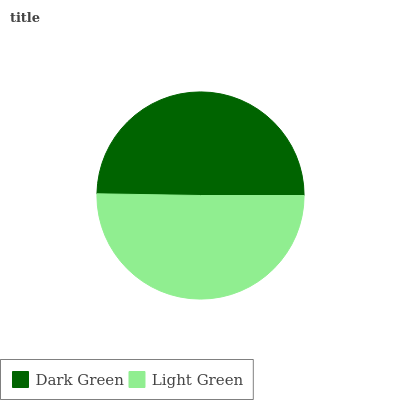Is Dark Green the minimum?
Answer yes or no. Yes. Is Light Green the maximum?
Answer yes or no. Yes. Is Light Green the minimum?
Answer yes or no. No. Is Light Green greater than Dark Green?
Answer yes or no. Yes. Is Dark Green less than Light Green?
Answer yes or no. Yes. Is Dark Green greater than Light Green?
Answer yes or no. No. Is Light Green less than Dark Green?
Answer yes or no. No. Is Light Green the high median?
Answer yes or no. Yes. Is Dark Green the low median?
Answer yes or no. Yes. Is Dark Green the high median?
Answer yes or no. No. Is Light Green the low median?
Answer yes or no. No. 